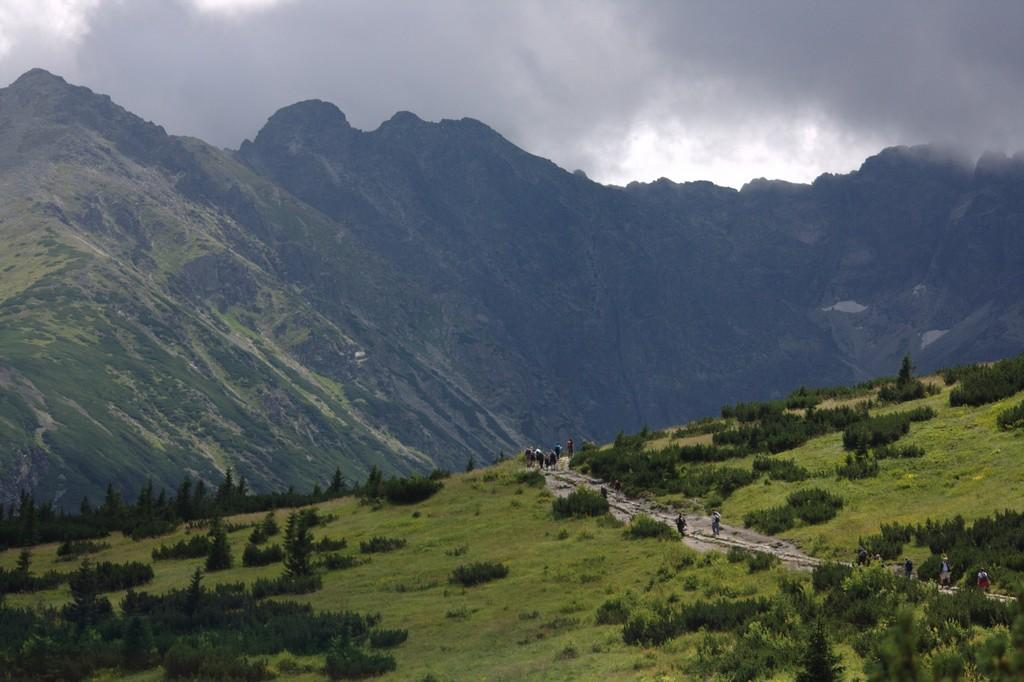What type of landscape is depicted in the image? There is a hill with trees and grass in the image. What else can be seen in the image besides the hill? There is a road in the image, and there are people on the road. What is visible in the background of the image? There are hills in the background of the image, and the sky is visible as well. What can be observed in the sky? Clouds are present in the sky. What type of animal is being judged by the farmer in the image? There is no farmer, animal, or judging activity present in the image. 